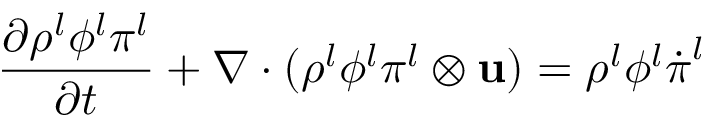Convert formula to latex. <formula><loc_0><loc_0><loc_500><loc_500>\frac { \partial \rho ^ { l } \phi ^ { l } \boldsymbol \pi ^ { l } } { \partial t } + \nabla \cdot ( \rho ^ { l } \phi ^ { l } \boldsymbol \pi ^ { l } \otimes u ) = \rho ^ { l } \phi ^ { l } \dot { \boldsymbol \pi } ^ { l }</formula> 